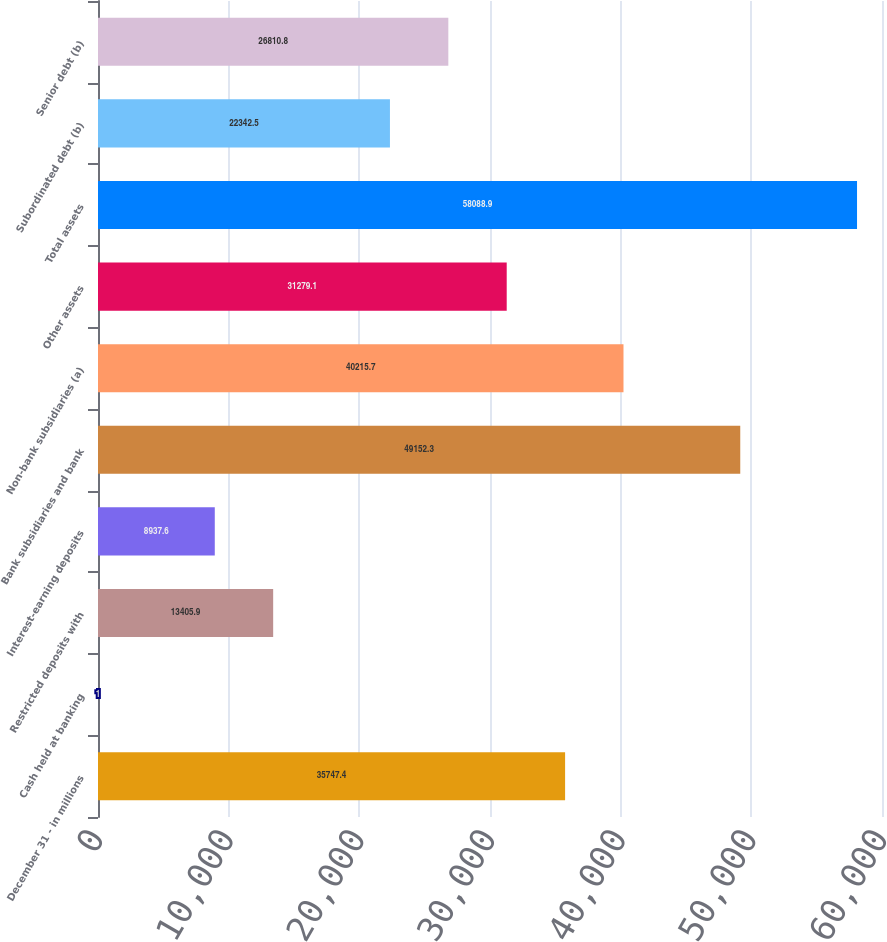Convert chart to OTSL. <chart><loc_0><loc_0><loc_500><loc_500><bar_chart><fcel>December 31 - in millions<fcel>Cash held at banking<fcel>Restricted deposits with<fcel>Interest-earning deposits<fcel>Bank subsidiaries and bank<fcel>Non-bank subsidiaries (a)<fcel>Other assets<fcel>Total assets<fcel>Subordinated debt (b)<fcel>Senior debt (b)<nl><fcel>35747.4<fcel>1<fcel>13405.9<fcel>8937.6<fcel>49152.3<fcel>40215.7<fcel>31279.1<fcel>58088.9<fcel>22342.5<fcel>26810.8<nl></chart> 